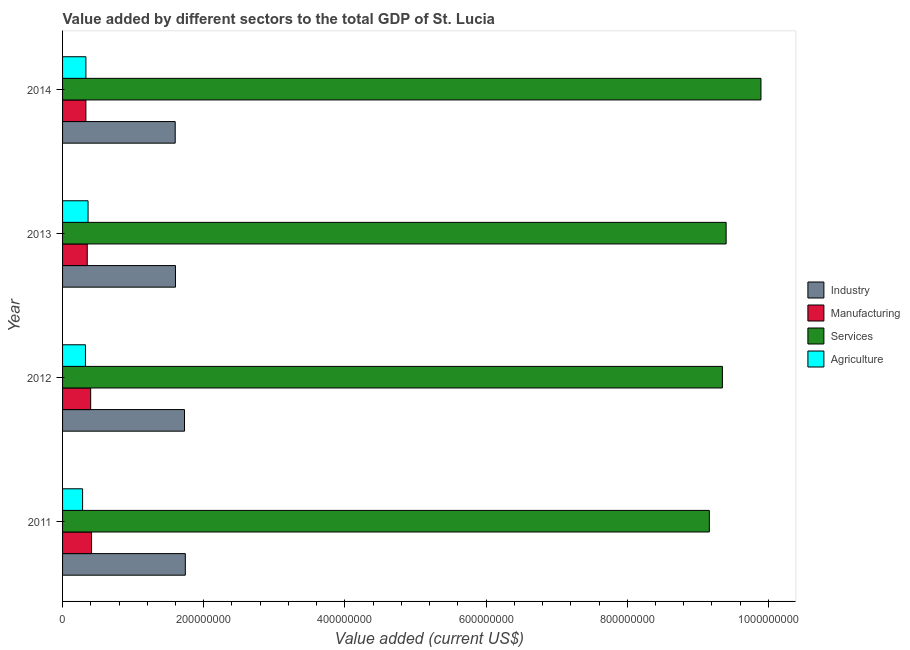How many groups of bars are there?
Provide a succinct answer. 4. What is the label of the 3rd group of bars from the top?
Make the answer very short. 2012. In how many cases, is the number of bars for a given year not equal to the number of legend labels?
Ensure brevity in your answer.  0. What is the value added by industrial sector in 2011?
Provide a succinct answer. 1.74e+08. Across all years, what is the maximum value added by manufacturing sector?
Your answer should be compact. 4.11e+07. Across all years, what is the minimum value added by services sector?
Provide a succinct answer. 9.16e+08. In which year was the value added by agricultural sector maximum?
Ensure brevity in your answer.  2013. In which year was the value added by industrial sector minimum?
Make the answer very short. 2014. What is the total value added by agricultural sector in the graph?
Your answer should be very brief. 1.30e+08. What is the difference between the value added by services sector in 2013 and that in 2014?
Ensure brevity in your answer.  -4.93e+07. What is the difference between the value added by services sector in 2013 and the value added by manufacturing sector in 2012?
Keep it short and to the point. 9.00e+08. What is the average value added by industrial sector per year?
Keep it short and to the point. 1.67e+08. In the year 2011, what is the difference between the value added by manufacturing sector and value added by agricultural sector?
Offer a very short reply. 1.27e+07. What is the ratio of the value added by manufacturing sector in 2011 to that in 2013?
Your answer should be very brief. 1.17. Is the value added by services sector in 2013 less than that in 2014?
Make the answer very short. Yes. Is the difference between the value added by manufacturing sector in 2011 and 2012 greater than the difference between the value added by industrial sector in 2011 and 2012?
Offer a very short reply. Yes. What is the difference between the highest and the second highest value added by services sector?
Your response must be concise. 4.93e+07. What is the difference between the highest and the lowest value added by manufacturing sector?
Your answer should be very brief. 8.04e+06. In how many years, is the value added by services sector greater than the average value added by services sector taken over all years?
Make the answer very short. 1. Is the sum of the value added by industrial sector in 2012 and 2013 greater than the maximum value added by manufacturing sector across all years?
Provide a succinct answer. Yes. Is it the case that in every year, the sum of the value added by services sector and value added by industrial sector is greater than the sum of value added by agricultural sector and value added by manufacturing sector?
Your answer should be very brief. Yes. What does the 3rd bar from the top in 2012 represents?
Keep it short and to the point. Manufacturing. What does the 2nd bar from the bottom in 2014 represents?
Give a very brief answer. Manufacturing. How many bars are there?
Keep it short and to the point. 16. Are all the bars in the graph horizontal?
Keep it short and to the point. Yes. Are the values on the major ticks of X-axis written in scientific E-notation?
Offer a very short reply. No. Does the graph contain grids?
Your answer should be compact. No. How many legend labels are there?
Keep it short and to the point. 4. What is the title of the graph?
Your response must be concise. Value added by different sectors to the total GDP of St. Lucia. Does "Salary of employees" appear as one of the legend labels in the graph?
Make the answer very short. No. What is the label or title of the X-axis?
Your response must be concise. Value added (current US$). What is the Value added (current US$) in Industry in 2011?
Provide a short and direct response. 1.74e+08. What is the Value added (current US$) in Manufacturing in 2011?
Ensure brevity in your answer.  4.11e+07. What is the Value added (current US$) of Services in 2011?
Make the answer very short. 9.16e+08. What is the Value added (current US$) of Agriculture in 2011?
Your answer should be compact. 2.84e+07. What is the Value added (current US$) in Industry in 2012?
Offer a very short reply. 1.73e+08. What is the Value added (current US$) of Manufacturing in 2012?
Make the answer very short. 3.98e+07. What is the Value added (current US$) of Services in 2012?
Provide a succinct answer. 9.35e+08. What is the Value added (current US$) of Agriculture in 2012?
Provide a succinct answer. 3.24e+07. What is the Value added (current US$) of Industry in 2013?
Make the answer very short. 1.60e+08. What is the Value added (current US$) in Manufacturing in 2013?
Provide a succinct answer. 3.50e+07. What is the Value added (current US$) of Services in 2013?
Keep it short and to the point. 9.40e+08. What is the Value added (current US$) in Agriculture in 2013?
Ensure brevity in your answer.  3.61e+07. What is the Value added (current US$) of Industry in 2014?
Make the answer very short. 1.60e+08. What is the Value added (current US$) of Manufacturing in 2014?
Offer a terse response. 3.30e+07. What is the Value added (current US$) in Services in 2014?
Ensure brevity in your answer.  9.89e+08. What is the Value added (current US$) in Agriculture in 2014?
Offer a terse response. 3.31e+07. Across all years, what is the maximum Value added (current US$) in Industry?
Keep it short and to the point. 1.74e+08. Across all years, what is the maximum Value added (current US$) in Manufacturing?
Make the answer very short. 4.11e+07. Across all years, what is the maximum Value added (current US$) in Services?
Provide a short and direct response. 9.89e+08. Across all years, what is the maximum Value added (current US$) of Agriculture?
Your answer should be compact. 3.61e+07. Across all years, what is the minimum Value added (current US$) of Industry?
Ensure brevity in your answer.  1.60e+08. Across all years, what is the minimum Value added (current US$) of Manufacturing?
Give a very brief answer. 3.30e+07. Across all years, what is the minimum Value added (current US$) of Services?
Your answer should be compact. 9.16e+08. Across all years, what is the minimum Value added (current US$) of Agriculture?
Keep it short and to the point. 2.84e+07. What is the total Value added (current US$) in Industry in the graph?
Give a very brief answer. 6.66e+08. What is the total Value added (current US$) of Manufacturing in the graph?
Your answer should be very brief. 1.49e+08. What is the total Value added (current US$) of Services in the graph?
Provide a short and direct response. 3.78e+09. What is the total Value added (current US$) of Agriculture in the graph?
Your answer should be very brief. 1.30e+08. What is the difference between the Value added (current US$) in Industry in 2011 and that in 2012?
Your answer should be compact. 1.18e+06. What is the difference between the Value added (current US$) of Manufacturing in 2011 and that in 2012?
Give a very brief answer. 1.24e+06. What is the difference between the Value added (current US$) of Services in 2011 and that in 2012?
Ensure brevity in your answer.  -1.85e+07. What is the difference between the Value added (current US$) of Agriculture in 2011 and that in 2012?
Your answer should be compact. -4.05e+06. What is the difference between the Value added (current US$) in Industry in 2011 and that in 2013?
Provide a succinct answer. 1.39e+07. What is the difference between the Value added (current US$) in Manufacturing in 2011 and that in 2013?
Your response must be concise. 6.10e+06. What is the difference between the Value added (current US$) of Services in 2011 and that in 2013?
Provide a short and direct response. -2.38e+07. What is the difference between the Value added (current US$) of Agriculture in 2011 and that in 2013?
Ensure brevity in your answer.  -7.74e+06. What is the difference between the Value added (current US$) in Industry in 2011 and that in 2014?
Give a very brief answer. 1.43e+07. What is the difference between the Value added (current US$) in Manufacturing in 2011 and that in 2014?
Offer a terse response. 8.04e+06. What is the difference between the Value added (current US$) in Services in 2011 and that in 2014?
Make the answer very short. -7.31e+07. What is the difference between the Value added (current US$) in Agriculture in 2011 and that in 2014?
Make the answer very short. -4.70e+06. What is the difference between the Value added (current US$) in Industry in 2012 and that in 2013?
Provide a succinct answer. 1.28e+07. What is the difference between the Value added (current US$) in Manufacturing in 2012 and that in 2013?
Provide a succinct answer. 4.86e+06. What is the difference between the Value added (current US$) in Services in 2012 and that in 2013?
Your response must be concise. -5.29e+06. What is the difference between the Value added (current US$) in Agriculture in 2012 and that in 2013?
Keep it short and to the point. -3.68e+06. What is the difference between the Value added (current US$) in Industry in 2012 and that in 2014?
Make the answer very short. 1.32e+07. What is the difference between the Value added (current US$) of Manufacturing in 2012 and that in 2014?
Offer a terse response. 6.79e+06. What is the difference between the Value added (current US$) of Services in 2012 and that in 2014?
Give a very brief answer. -5.46e+07. What is the difference between the Value added (current US$) in Agriculture in 2012 and that in 2014?
Your answer should be compact. -6.43e+05. What is the difference between the Value added (current US$) of Industry in 2013 and that in 2014?
Offer a terse response. 4.03e+05. What is the difference between the Value added (current US$) in Manufacturing in 2013 and that in 2014?
Make the answer very short. 1.94e+06. What is the difference between the Value added (current US$) of Services in 2013 and that in 2014?
Make the answer very short. -4.93e+07. What is the difference between the Value added (current US$) in Agriculture in 2013 and that in 2014?
Your answer should be compact. 3.04e+06. What is the difference between the Value added (current US$) in Industry in 2011 and the Value added (current US$) in Manufacturing in 2012?
Keep it short and to the point. 1.34e+08. What is the difference between the Value added (current US$) of Industry in 2011 and the Value added (current US$) of Services in 2012?
Your answer should be compact. -7.61e+08. What is the difference between the Value added (current US$) of Industry in 2011 and the Value added (current US$) of Agriculture in 2012?
Keep it short and to the point. 1.41e+08. What is the difference between the Value added (current US$) in Manufacturing in 2011 and the Value added (current US$) in Services in 2012?
Make the answer very short. -8.94e+08. What is the difference between the Value added (current US$) in Manufacturing in 2011 and the Value added (current US$) in Agriculture in 2012?
Make the answer very short. 8.64e+06. What is the difference between the Value added (current US$) of Services in 2011 and the Value added (current US$) of Agriculture in 2012?
Ensure brevity in your answer.  8.84e+08. What is the difference between the Value added (current US$) in Industry in 2011 and the Value added (current US$) in Manufacturing in 2013?
Your answer should be very brief. 1.39e+08. What is the difference between the Value added (current US$) of Industry in 2011 and the Value added (current US$) of Services in 2013?
Give a very brief answer. -7.66e+08. What is the difference between the Value added (current US$) in Industry in 2011 and the Value added (current US$) in Agriculture in 2013?
Offer a very short reply. 1.38e+08. What is the difference between the Value added (current US$) in Manufacturing in 2011 and the Value added (current US$) in Services in 2013?
Your answer should be compact. -8.99e+08. What is the difference between the Value added (current US$) of Manufacturing in 2011 and the Value added (current US$) of Agriculture in 2013?
Provide a succinct answer. 4.96e+06. What is the difference between the Value added (current US$) in Services in 2011 and the Value added (current US$) in Agriculture in 2013?
Your answer should be compact. 8.80e+08. What is the difference between the Value added (current US$) in Industry in 2011 and the Value added (current US$) in Manufacturing in 2014?
Provide a short and direct response. 1.41e+08. What is the difference between the Value added (current US$) of Industry in 2011 and the Value added (current US$) of Services in 2014?
Offer a very short reply. -8.15e+08. What is the difference between the Value added (current US$) of Industry in 2011 and the Value added (current US$) of Agriculture in 2014?
Provide a succinct answer. 1.41e+08. What is the difference between the Value added (current US$) in Manufacturing in 2011 and the Value added (current US$) in Services in 2014?
Give a very brief answer. -9.48e+08. What is the difference between the Value added (current US$) of Manufacturing in 2011 and the Value added (current US$) of Agriculture in 2014?
Your response must be concise. 8.00e+06. What is the difference between the Value added (current US$) in Services in 2011 and the Value added (current US$) in Agriculture in 2014?
Provide a short and direct response. 8.83e+08. What is the difference between the Value added (current US$) in Industry in 2012 and the Value added (current US$) in Manufacturing in 2013?
Ensure brevity in your answer.  1.38e+08. What is the difference between the Value added (current US$) of Industry in 2012 and the Value added (current US$) of Services in 2013?
Provide a succinct answer. -7.67e+08. What is the difference between the Value added (current US$) of Industry in 2012 and the Value added (current US$) of Agriculture in 2013?
Provide a succinct answer. 1.37e+08. What is the difference between the Value added (current US$) of Manufacturing in 2012 and the Value added (current US$) of Services in 2013?
Offer a very short reply. -9.00e+08. What is the difference between the Value added (current US$) in Manufacturing in 2012 and the Value added (current US$) in Agriculture in 2013?
Give a very brief answer. 3.71e+06. What is the difference between the Value added (current US$) of Services in 2012 and the Value added (current US$) of Agriculture in 2013?
Your answer should be very brief. 8.99e+08. What is the difference between the Value added (current US$) of Industry in 2012 and the Value added (current US$) of Manufacturing in 2014?
Your answer should be very brief. 1.40e+08. What is the difference between the Value added (current US$) of Industry in 2012 and the Value added (current US$) of Services in 2014?
Make the answer very short. -8.17e+08. What is the difference between the Value added (current US$) of Industry in 2012 and the Value added (current US$) of Agriculture in 2014?
Give a very brief answer. 1.40e+08. What is the difference between the Value added (current US$) of Manufacturing in 2012 and the Value added (current US$) of Services in 2014?
Make the answer very short. -9.50e+08. What is the difference between the Value added (current US$) in Manufacturing in 2012 and the Value added (current US$) in Agriculture in 2014?
Your answer should be compact. 6.76e+06. What is the difference between the Value added (current US$) of Services in 2012 and the Value added (current US$) of Agriculture in 2014?
Offer a very short reply. 9.02e+08. What is the difference between the Value added (current US$) in Industry in 2013 and the Value added (current US$) in Manufacturing in 2014?
Provide a succinct answer. 1.27e+08. What is the difference between the Value added (current US$) of Industry in 2013 and the Value added (current US$) of Services in 2014?
Your answer should be very brief. -8.29e+08. What is the difference between the Value added (current US$) of Industry in 2013 and the Value added (current US$) of Agriculture in 2014?
Your answer should be compact. 1.27e+08. What is the difference between the Value added (current US$) in Manufacturing in 2013 and the Value added (current US$) in Services in 2014?
Make the answer very short. -9.54e+08. What is the difference between the Value added (current US$) of Manufacturing in 2013 and the Value added (current US$) of Agriculture in 2014?
Your response must be concise. 1.90e+06. What is the difference between the Value added (current US$) in Services in 2013 and the Value added (current US$) in Agriculture in 2014?
Your answer should be very brief. 9.07e+08. What is the average Value added (current US$) in Industry per year?
Your response must be concise. 1.67e+08. What is the average Value added (current US$) of Manufacturing per year?
Keep it short and to the point. 3.72e+07. What is the average Value added (current US$) of Services per year?
Ensure brevity in your answer.  9.45e+08. What is the average Value added (current US$) of Agriculture per year?
Your answer should be compact. 3.25e+07. In the year 2011, what is the difference between the Value added (current US$) in Industry and Value added (current US$) in Manufacturing?
Offer a very short reply. 1.33e+08. In the year 2011, what is the difference between the Value added (current US$) of Industry and Value added (current US$) of Services?
Ensure brevity in your answer.  -7.42e+08. In the year 2011, what is the difference between the Value added (current US$) in Industry and Value added (current US$) in Agriculture?
Provide a short and direct response. 1.46e+08. In the year 2011, what is the difference between the Value added (current US$) of Manufacturing and Value added (current US$) of Services?
Your response must be concise. -8.75e+08. In the year 2011, what is the difference between the Value added (current US$) in Manufacturing and Value added (current US$) in Agriculture?
Give a very brief answer. 1.27e+07. In the year 2011, what is the difference between the Value added (current US$) of Services and Value added (current US$) of Agriculture?
Offer a very short reply. 8.88e+08. In the year 2012, what is the difference between the Value added (current US$) of Industry and Value added (current US$) of Manufacturing?
Your answer should be very brief. 1.33e+08. In the year 2012, what is the difference between the Value added (current US$) of Industry and Value added (current US$) of Services?
Give a very brief answer. -7.62e+08. In the year 2012, what is the difference between the Value added (current US$) in Industry and Value added (current US$) in Agriculture?
Keep it short and to the point. 1.40e+08. In the year 2012, what is the difference between the Value added (current US$) of Manufacturing and Value added (current US$) of Services?
Provide a succinct answer. -8.95e+08. In the year 2012, what is the difference between the Value added (current US$) in Manufacturing and Value added (current US$) in Agriculture?
Your answer should be compact. 7.40e+06. In the year 2012, what is the difference between the Value added (current US$) of Services and Value added (current US$) of Agriculture?
Your answer should be very brief. 9.02e+08. In the year 2013, what is the difference between the Value added (current US$) in Industry and Value added (current US$) in Manufacturing?
Offer a very short reply. 1.25e+08. In the year 2013, what is the difference between the Value added (current US$) in Industry and Value added (current US$) in Services?
Give a very brief answer. -7.80e+08. In the year 2013, what is the difference between the Value added (current US$) in Industry and Value added (current US$) in Agriculture?
Your answer should be compact. 1.24e+08. In the year 2013, what is the difference between the Value added (current US$) of Manufacturing and Value added (current US$) of Services?
Provide a succinct answer. -9.05e+08. In the year 2013, what is the difference between the Value added (current US$) of Manufacturing and Value added (current US$) of Agriculture?
Your answer should be compact. -1.14e+06. In the year 2013, what is the difference between the Value added (current US$) of Services and Value added (current US$) of Agriculture?
Keep it short and to the point. 9.04e+08. In the year 2014, what is the difference between the Value added (current US$) of Industry and Value added (current US$) of Manufacturing?
Provide a succinct answer. 1.27e+08. In the year 2014, what is the difference between the Value added (current US$) of Industry and Value added (current US$) of Services?
Ensure brevity in your answer.  -8.30e+08. In the year 2014, what is the difference between the Value added (current US$) of Industry and Value added (current US$) of Agriculture?
Offer a terse response. 1.27e+08. In the year 2014, what is the difference between the Value added (current US$) in Manufacturing and Value added (current US$) in Services?
Give a very brief answer. -9.56e+08. In the year 2014, what is the difference between the Value added (current US$) of Manufacturing and Value added (current US$) of Agriculture?
Your answer should be compact. -3.81e+04. In the year 2014, what is the difference between the Value added (current US$) in Services and Value added (current US$) in Agriculture?
Your answer should be very brief. 9.56e+08. What is the ratio of the Value added (current US$) in Industry in 2011 to that in 2012?
Your response must be concise. 1.01. What is the ratio of the Value added (current US$) of Manufacturing in 2011 to that in 2012?
Your answer should be very brief. 1.03. What is the ratio of the Value added (current US$) in Services in 2011 to that in 2012?
Give a very brief answer. 0.98. What is the ratio of the Value added (current US$) in Agriculture in 2011 to that in 2012?
Provide a succinct answer. 0.88. What is the ratio of the Value added (current US$) in Industry in 2011 to that in 2013?
Ensure brevity in your answer.  1.09. What is the ratio of the Value added (current US$) of Manufacturing in 2011 to that in 2013?
Give a very brief answer. 1.17. What is the ratio of the Value added (current US$) of Services in 2011 to that in 2013?
Make the answer very short. 0.97. What is the ratio of the Value added (current US$) in Agriculture in 2011 to that in 2013?
Provide a succinct answer. 0.79. What is the ratio of the Value added (current US$) of Industry in 2011 to that in 2014?
Offer a very short reply. 1.09. What is the ratio of the Value added (current US$) of Manufacturing in 2011 to that in 2014?
Offer a terse response. 1.24. What is the ratio of the Value added (current US$) of Services in 2011 to that in 2014?
Your answer should be compact. 0.93. What is the ratio of the Value added (current US$) in Agriculture in 2011 to that in 2014?
Your answer should be compact. 0.86. What is the ratio of the Value added (current US$) of Industry in 2012 to that in 2013?
Offer a very short reply. 1.08. What is the ratio of the Value added (current US$) of Manufacturing in 2012 to that in 2013?
Offer a terse response. 1.14. What is the ratio of the Value added (current US$) in Agriculture in 2012 to that in 2013?
Ensure brevity in your answer.  0.9. What is the ratio of the Value added (current US$) in Industry in 2012 to that in 2014?
Your response must be concise. 1.08. What is the ratio of the Value added (current US$) of Manufacturing in 2012 to that in 2014?
Provide a short and direct response. 1.21. What is the ratio of the Value added (current US$) of Services in 2012 to that in 2014?
Make the answer very short. 0.94. What is the ratio of the Value added (current US$) in Agriculture in 2012 to that in 2014?
Ensure brevity in your answer.  0.98. What is the ratio of the Value added (current US$) in Industry in 2013 to that in 2014?
Your answer should be very brief. 1. What is the ratio of the Value added (current US$) of Manufacturing in 2013 to that in 2014?
Offer a terse response. 1.06. What is the ratio of the Value added (current US$) in Services in 2013 to that in 2014?
Your answer should be very brief. 0.95. What is the ratio of the Value added (current US$) in Agriculture in 2013 to that in 2014?
Make the answer very short. 1.09. What is the difference between the highest and the second highest Value added (current US$) of Industry?
Provide a succinct answer. 1.18e+06. What is the difference between the highest and the second highest Value added (current US$) of Manufacturing?
Make the answer very short. 1.24e+06. What is the difference between the highest and the second highest Value added (current US$) of Services?
Offer a very short reply. 4.93e+07. What is the difference between the highest and the second highest Value added (current US$) of Agriculture?
Your answer should be compact. 3.04e+06. What is the difference between the highest and the lowest Value added (current US$) in Industry?
Offer a very short reply. 1.43e+07. What is the difference between the highest and the lowest Value added (current US$) of Manufacturing?
Your answer should be compact. 8.04e+06. What is the difference between the highest and the lowest Value added (current US$) in Services?
Ensure brevity in your answer.  7.31e+07. What is the difference between the highest and the lowest Value added (current US$) in Agriculture?
Provide a succinct answer. 7.74e+06. 